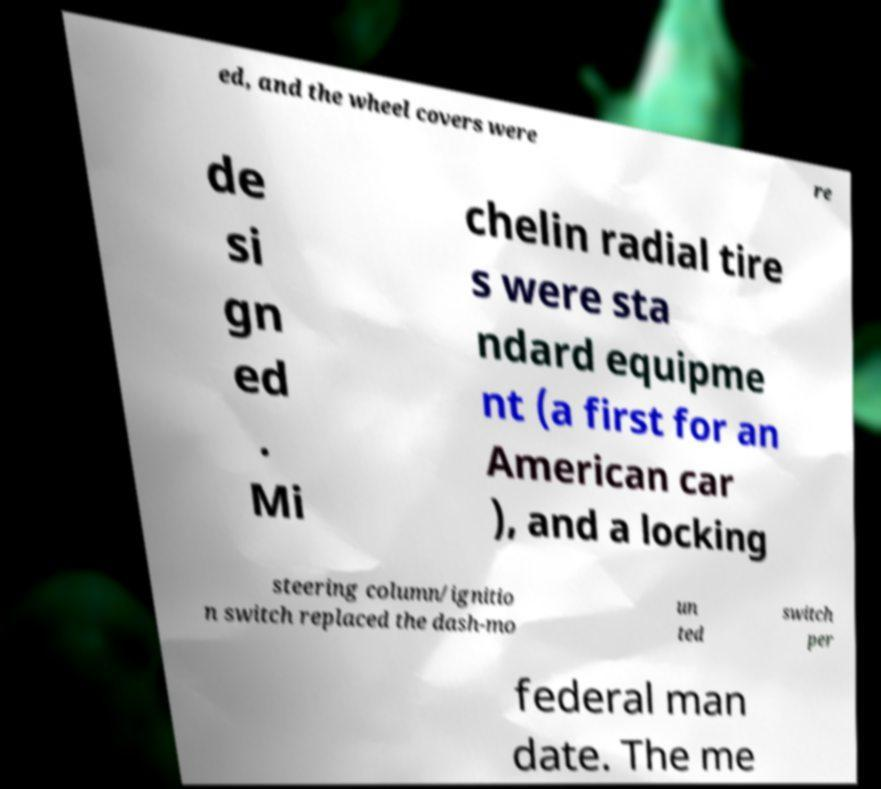For documentation purposes, I need the text within this image transcribed. Could you provide that? ed, and the wheel covers were re de si gn ed . Mi chelin radial tire s were sta ndard equipme nt (a first for an American car ), and a locking steering column/ignitio n switch replaced the dash-mo un ted switch per federal man date. The me 